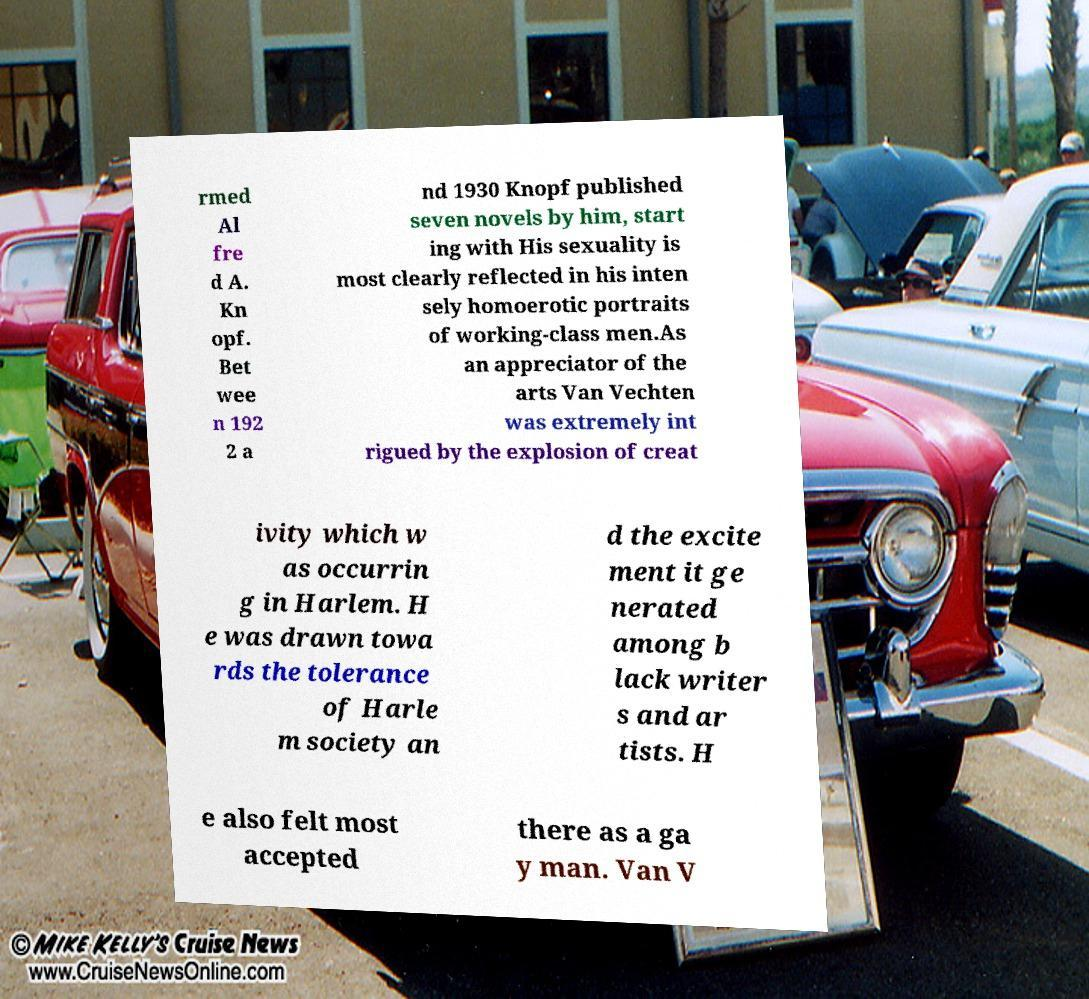There's text embedded in this image that I need extracted. Can you transcribe it verbatim? rmed Al fre d A. Kn opf. Bet wee n 192 2 a nd 1930 Knopf published seven novels by him, start ing with His sexuality is most clearly reflected in his inten sely homoerotic portraits of working-class men.As an appreciator of the arts Van Vechten was extremely int rigued by the explosion of creat ivity which w as occurrin g in Harlem. H e was drawn towa rds the tolerance of Harle m society an d the excite ment it ge nerated among b lack writer s and ar tists. H e also felt most accepted there as a ga y man. Van V 